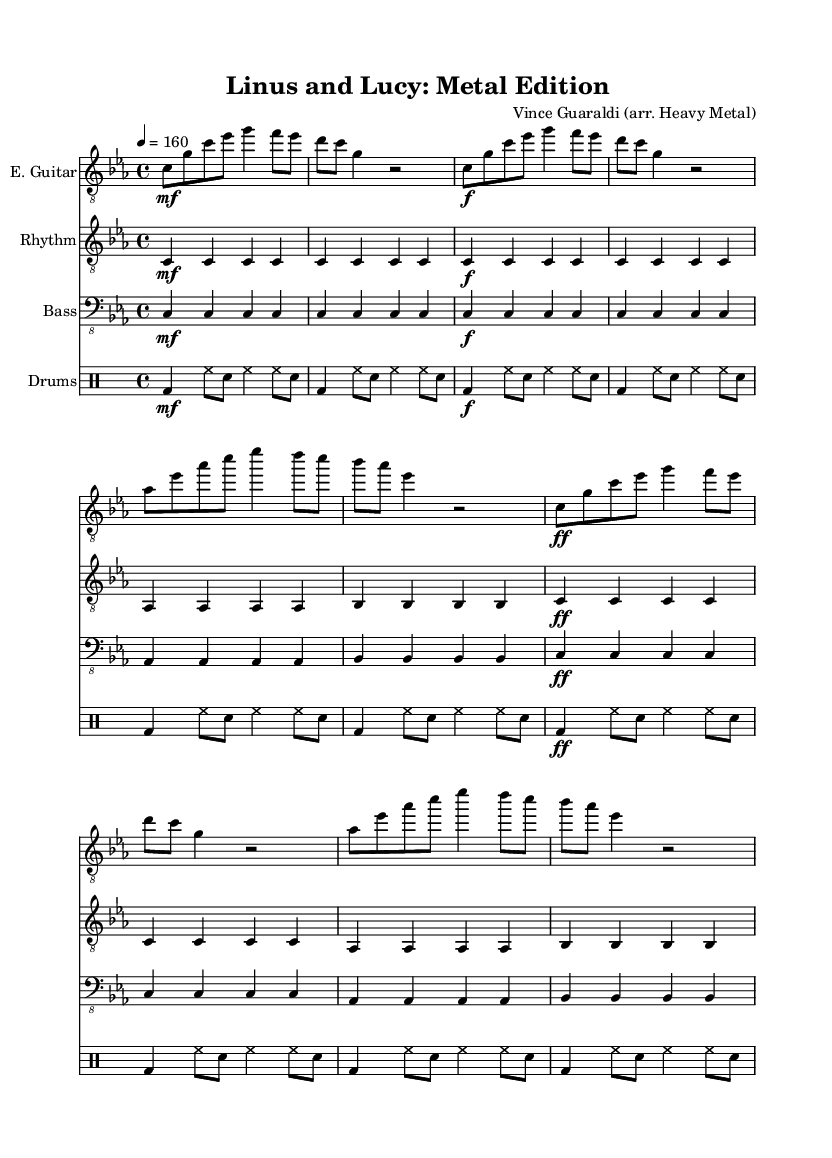What is the key signature of this music? The key signature is C minor, which contains three flats: B flat, E flat, and A flat. This can be determined from the key signature section at the beginning of the score.
Answer: C minor What is the time signature of this piece? The time signature is 4/4, indicated at the start of the score, meaning there are four beats in each measure and a quarter note receives one beat.
Answer: 4/4 What tempo is indicated for this arrangement? The tempo marking shows a speed of 160 beats per minute, as indicated next to the \tempo directive at the beginning of the score.
Answer: 160 How many measures are in the intro section? The intro consists of 2 measures, which can be counted from the provided notes under the electric guitar part before the verse begins.
Answer: 2 What dynamic marking starts the chorus section? The chorus section begins with a fortissimo marking, indicating that it should be played very loudly. This can be found at the beginning of the chorus, where the dynamic is noted as "ff."
Answer: fortissimo Which instrument has the power chords written? The rhythm guitar part contains the power chords, which are indicated by the notation showing the chord names and their placement in the score. The rhythm guitar staff clearly has this under its instrument name.
Answer: Rhythm Guitar How does the bass guitar correspond with the electric guitar in the verse? The bass guitar follows the same rhythmic pattern as the electric guitar in the verse, which can be analyzed by observing the similarities in note values and how they relate to the electric guitar part, effectively reinforcing the harmonic structure.
Answer: Same rhythmic pattern 